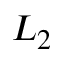<formula> <loc_0><loc_0><loc_500><loc_500>L _ { 2 }</formula> 